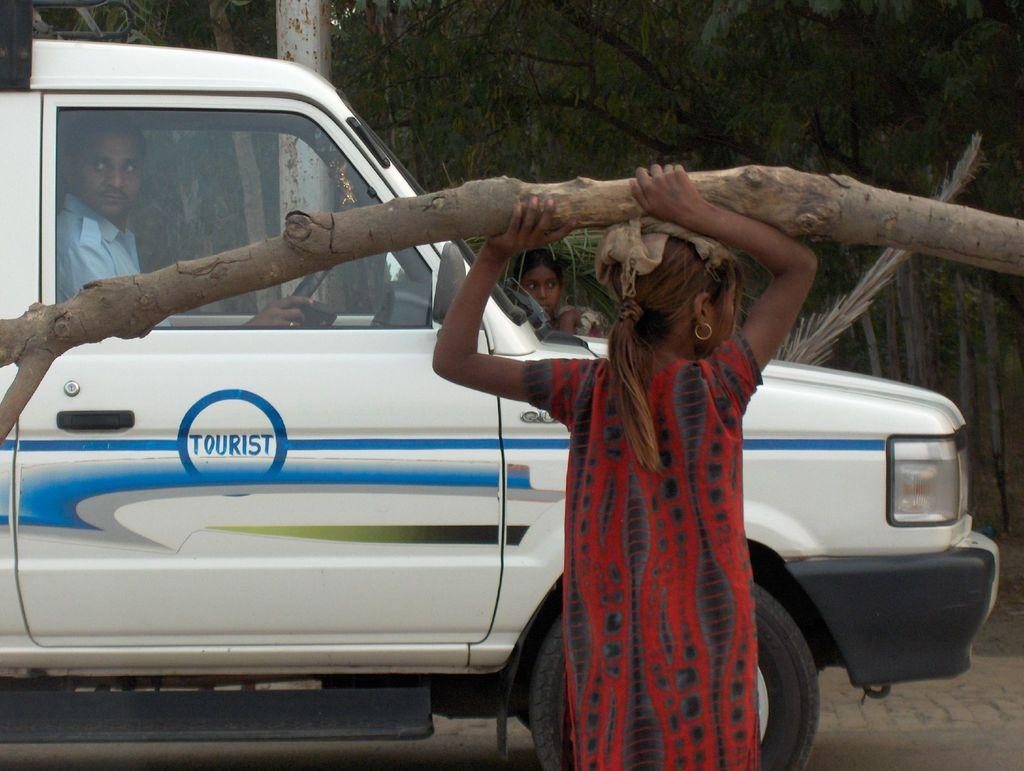What is the girl holding in the image? The girl is holding a wooden log in the image. What is the man doing in the image? The man is sitting in a vehicle in the image. What can be seen behind the vehicle? Trees and a pole are visible behind the vehicle in the image. Is there anyone else present in the image? Yes, there is a person behind the vehicle in the image. What type of eggs can be seen on the wooden log in the image? There are no eggs present in the image; the girl is holding a wooden log. What type of quartz can be seen on the pole behind the vehicle in the image? There is no quartz present in the image; the pole is just a pole. 